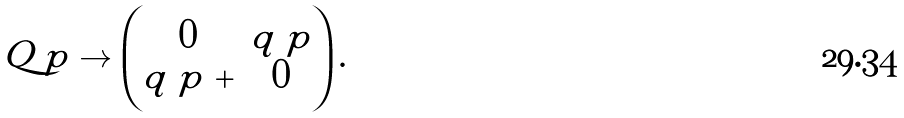<formula> <loc_0><loc_0><loc_500><loc_500>Q _ { \ } p \to \begin{pmatrix} 0 & q _ { \ } p \\ q _ { \ } p ^ { \ } + & 0 \end{pmatrix} .</formula> 